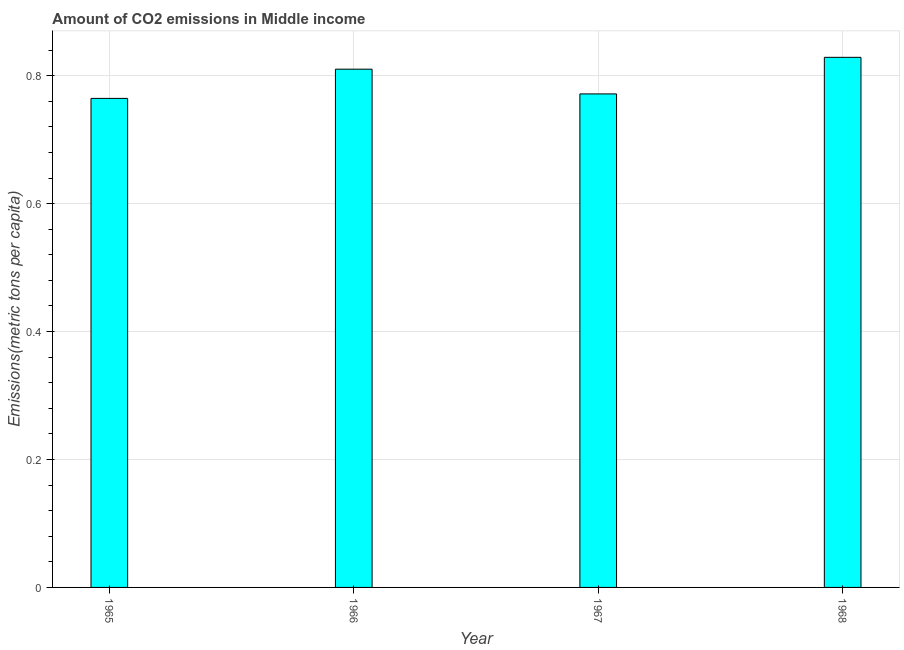What is the title of the graph?
Offer a very short reply. Amount of CO2 emissions in Middle income. What is the label or title of the Y-axis?
Give a very brief answer. Emissions(metric tons per capita). What is the amount of co2 emissions in 1968?
Keep it short and to the point. 0.83. Across all years, what is the maximum amount of co2 emissions?
Your response must be concise. 0.83. Across all years, what is the minimum amount of co2 emissions?
Offer a very short reply. 0.76. In which year was the amount of co2 emissions maximum?
Offer a very short reply. 1968. In which year was the amount of co2 emissions minimum?
Your response must be concise. 1965. What is the sum of the amount of co2 emissions?
Offer a terse response. 3.17. What is the difference between the amount of co2 emissions in 1966 and 1967?
Ensure brevity in your answer.  0.04. What is the average amount of co2 emissions per year?
Offer a terse response. 0.79. What is the median amount of co2 emissions?
Your response must be concise. 0.79. In how many years, is the amount of co2 emissions greater than 0.56 metric tons per capita?
Offer a very short reply. 4. Is the amount of co2 emissions in 1966 less than that in 1968?
Offer a very short reply. Yes. What is the difference between the highest and the second highest amount of co2 emissions?
Make the answer very short. 0.02. Is the sum of the amount of co2 emissions in 1966 and 1967 greater than the maximum amount of co2 emissions across all years?
Provide a succinct answer. Yes. In how many years, is the amount of co2 emissions greater than the average amount of co2 emissions taken over all years?
Offer a very short reply. 2. What is the Emissions(metric tons per capita) in 1965?
Provide a short and direct response. 0.76. What is the Emissions(metric tons per capita) of 1966?
Your answer should be compact. 0.81. What is the Emissions(metric tons per capita) in 1967?
Provide a short and direct response. 0.77. What is the Emissions(metric tons per capita) of 1968?
Ensure brevity in your answer.  0.83. What is the difference between the Emissions(metric tons per capita) in 1965 and 1966?
Your response must be concise. -0.05. What is the difference between the Emissions(metric tons per capita) in 1965 and 1967?
Give a very brief answer. -0.01. What is the difference between the Emissions(metric tons per capita) in 1965 and 1968?
Your answer should be compact. -0.06. What is the difference between the Emissions(metric tons per capita) in 1966 and 1967?
Make the answer very short. 0.04. What is the difference between the Emissions(metric tons per capita) in 1966 and 1968?
Your answer should be very brief. -0.02. What is the difference between the Emissions(metric tons per capita) in 1967 and 1968?
Your answer should be compact. -0.06. What is the ratio of the Emissions(metric tons per capita) in 1965 to that in 1966?
Your answer should be very brief. 0.94. What is the ratio of the Emissions(metric tons per capita) in 1965 to that in 1968?
Provide a succinct answer. 0.92. What is the ratio of the Emissions(metric tons per capita) in 1966 to that in 1967?
Ensure brevity in your answer.  1.05. 